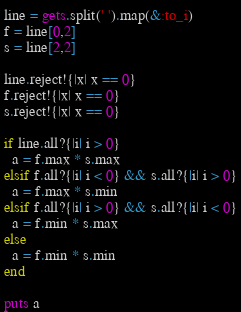<code> <loc_0><loc_0><loc_500><loc_500><_Ruby_>line = gets.split(' ').map(&:to_i)
f = line[0,2]
s = line[2,2]

line.reject!{|x| x == 0}
f.reject!{|x| x == 0}
s.reject!{|x| x == 0}

if line.all?{|i| i > 0}
  a = f.max * s.max
elsif f.all?{|i| i < 0} && s.all?{|i| i > 0}
  a = f.max * s.min
elsif f.all?{|i| i > 0} && s.all?{|i| i < 0}
  a = f.min * s.max
else
  a = f.min * s.min
end

puts a</code> 